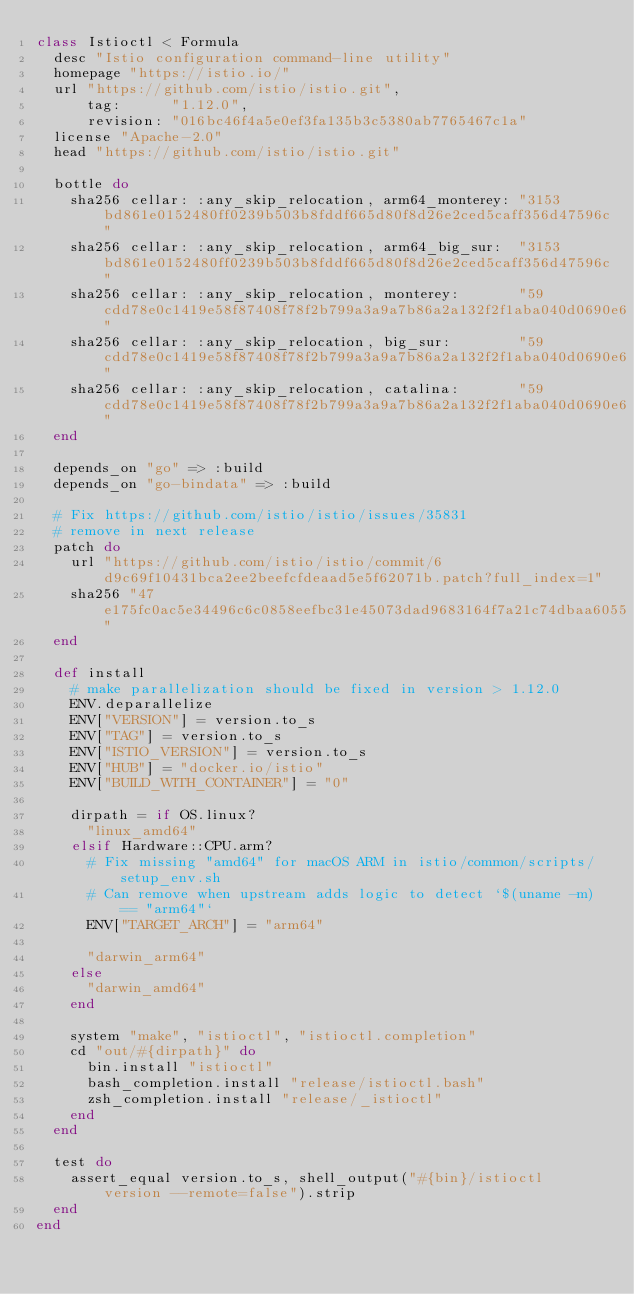<code> <loc_0><loc_0><loc_500><loc_500><_Ruby_>class Istioctl < Formula
  desc "Istio configuration command-line utility"
  homepage "https://istio.io/"
  url "https://github.com/istio/istio.git",
      tag:      "1.12.0",
      revision: "016bc46f4a5e0ef3fa135b3c5380ab7765467c1a"
  license "Apache-2.0"
  head "https://github.com/istio/istio.git"

  bottle do
    sha256 cellar: :any_skip_relocation, arm64_monterey: "3153bd861e0152480ff0239b503b8fddf665d80f8d26e2ced5caff356d47596c"
    sha256 cellar: :any_skip_relocation, arm64_big_sur:  "3153bd861e0152480ff0239b503b8fddf665d80f8d26e2ced5caff356d47596c"
    sha256 cellar: :any_skip_relocation, monterey:       "59cdd78e0c1419e58f87408f78f2b799a3a9a7b86a2a132f2f1aba040d0690e6"
    sha256 cellar: :any_skip_relocation, big_sur:        "59cdd78e0c1419e58f87408f78f2b799a3a9a7b86a2a132f2f1aba040d0690e6"
    sha256 cellar: :any_skip_relocation, catalina:       "59cdd78e0c1419e58f87408f78f2b799a3a9a7b86a2a132f2f1aba040d0690e6"
  end

  depends_on "go" => :build
  depends_on "go-bindata" => :build

  # Fix https://github.com/istio/istio/issues/35831
  # remove in next release
  patch do
    url "https://github.com/istio/istio/commit/6d9c69f10431bca2ee2beefcfdeaad5e5f62071b.patch?full_index=1"
    sha256 "47e175fc0ac5e34496c6c0858eefbc31e45073dad9683164f7a21c74dbaa6055"
  end

  def install
    # make parallelization should be fixed in version > 1.12.0
    ENV.deparallelize
    ENV["VERSION"] = version.to_s
    ENV["TAG"] = version.to_s
    ENV["ISTIO_VERSION"] = version.to_s
    ENV["HUB"] = "docker.io/istio"
    ENV["BUILD_WITH_CONTAINER"] = "0"

    dirpath = if OS.linux?
      "linux_amd64"
    elsif Hardware::CPU.arm?
      # Fix missing "amd64" for macOS ARM in istio/common/scripts/setup_env.sh
      # Can remove when upstream adds logic to detect `$(uname -m) == "arm64"`
      ENV["TARGET_ARCH"] = "arm64"

      "darwin_arm64"
    else
      "darwin_amd64"
    end

    system "make", "istioctl", "istioctl.completion"
    cd "out/#{dirpath}" do
      bin.install "istioctl"
      bash_completion.install "release/istioctl.bash"
      zsh_completion.install "release/_istioctl"
    end
  end

  test do
    assert_equal version.to_s, shell_output("#{bin}/istioctl version --remote=false").strip
  end
end
</code> 